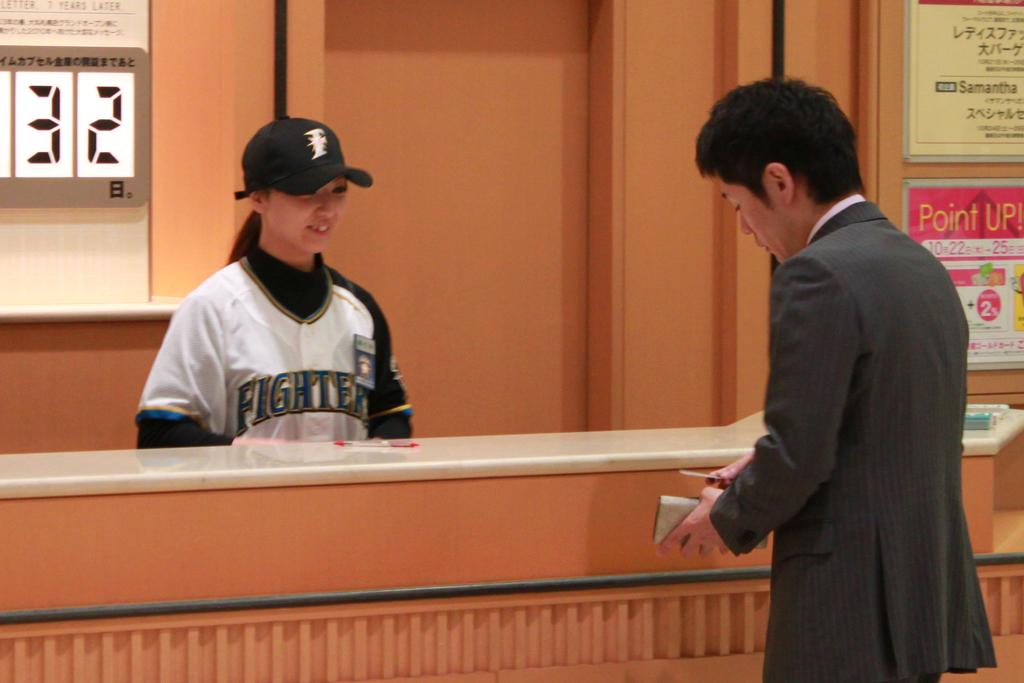<image>
Offer a succinct explanation of the picture presented. Next to a man is a sign with Point up! on it. 